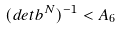<formula> <loc_0><loc_0><loc_500><loc_500>( d e t b ^ { N } ) ^ { - 1 } < A _ { 6 }</formula> 